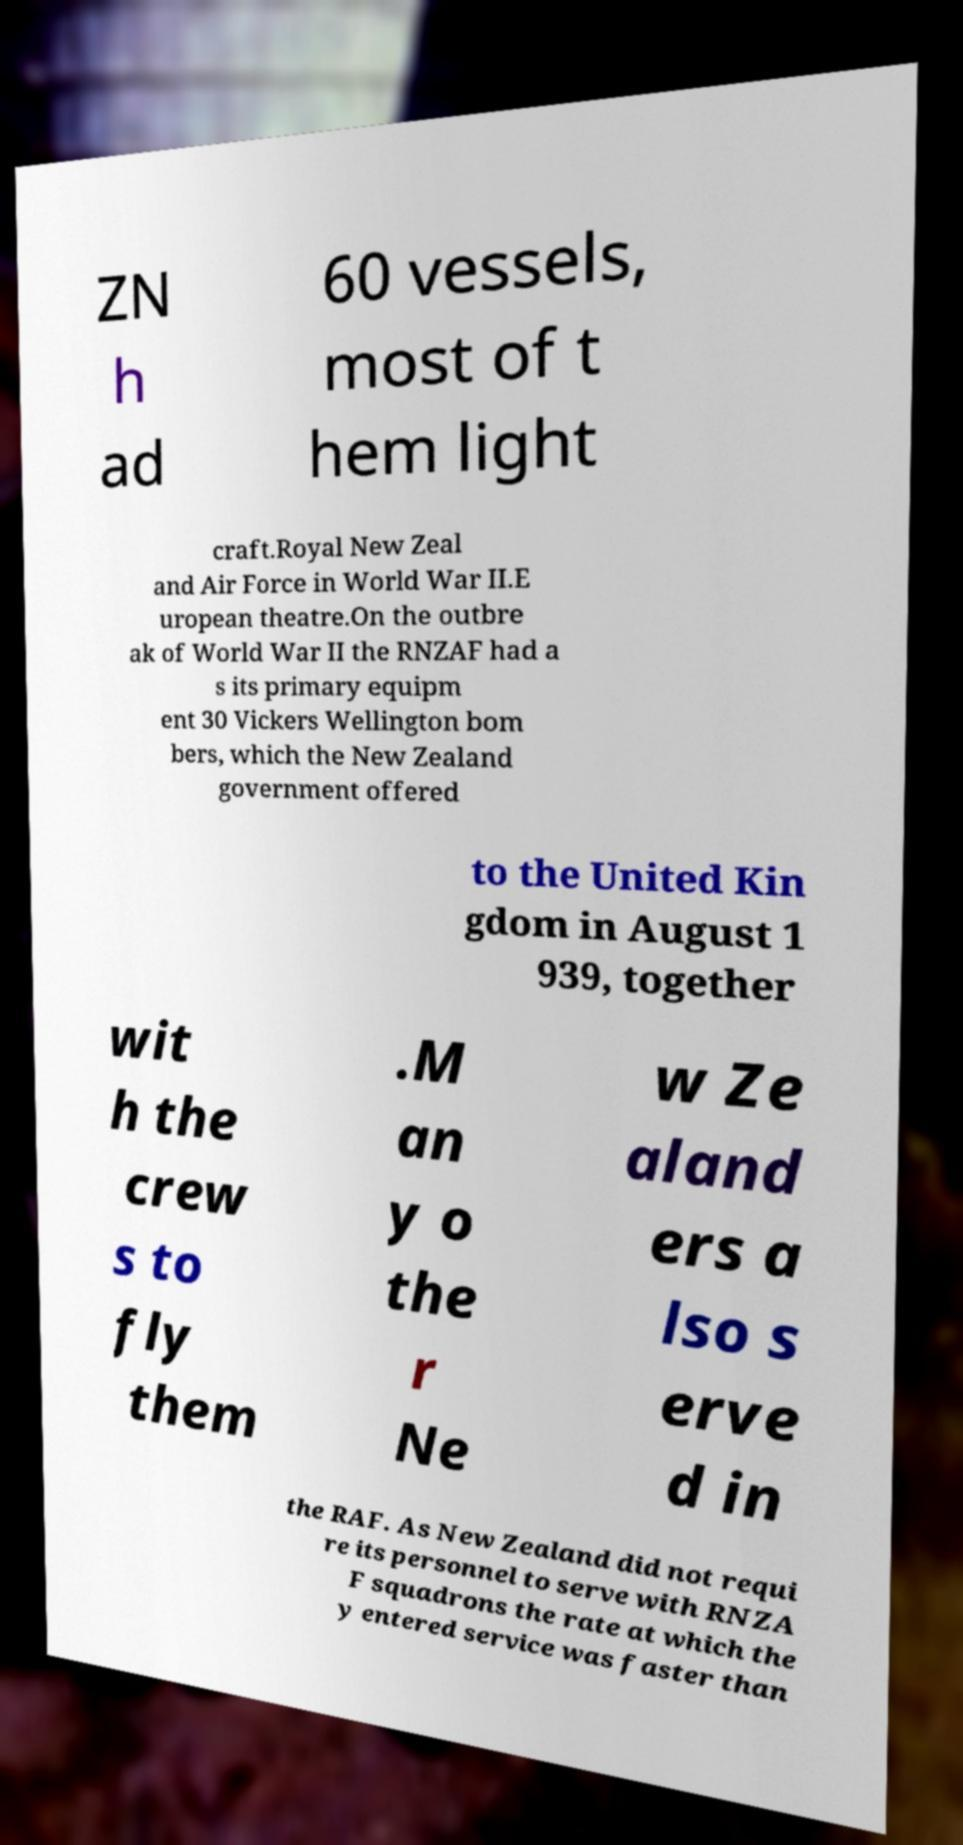Can you read and provide the text displayed in the image?This photo seems to have some interesting text. Can you extract and type it out for me? ZN h ad 60 vessels, most of t hem light craft.Royal New Zeal and Air Force in World War II.E uropean theatre.On the outbre ak of World War II the RNZAF had a s its primary equipm ent 30 Vickers Wellington bom bers, which the New Zealand government offered to the United Kin gdom in August 1 939, together wit h the crew s to fly them .M an y o the r Ne w Ze aland ers a lso s erve d in the RAF. As New Zealand did not requi re its personnel to serve with RNZA F squadrons the rate at which the y entered service was faster than 